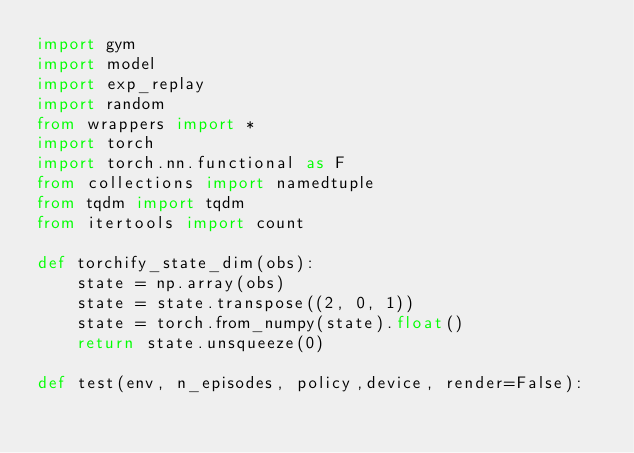Convert code to text. <code><loc_0><loc_0><loc_500><loc_500><_Python_>import gym
import model
import exp_replay
import random
from wrappers import *
import torch
import torch.nn.functional as F
from collections import namedtuple
from tqdm import tqdm
from itertools import count

def torchify_state_dim(obs):
    state = np.array(obs)
    state = state.transpose((2, 0, 1))
    state = torch.from_numpy(state).float()
    return state.unsqueeze(0)

def test(env, n_episodes, policy,device, render=False):</code> 